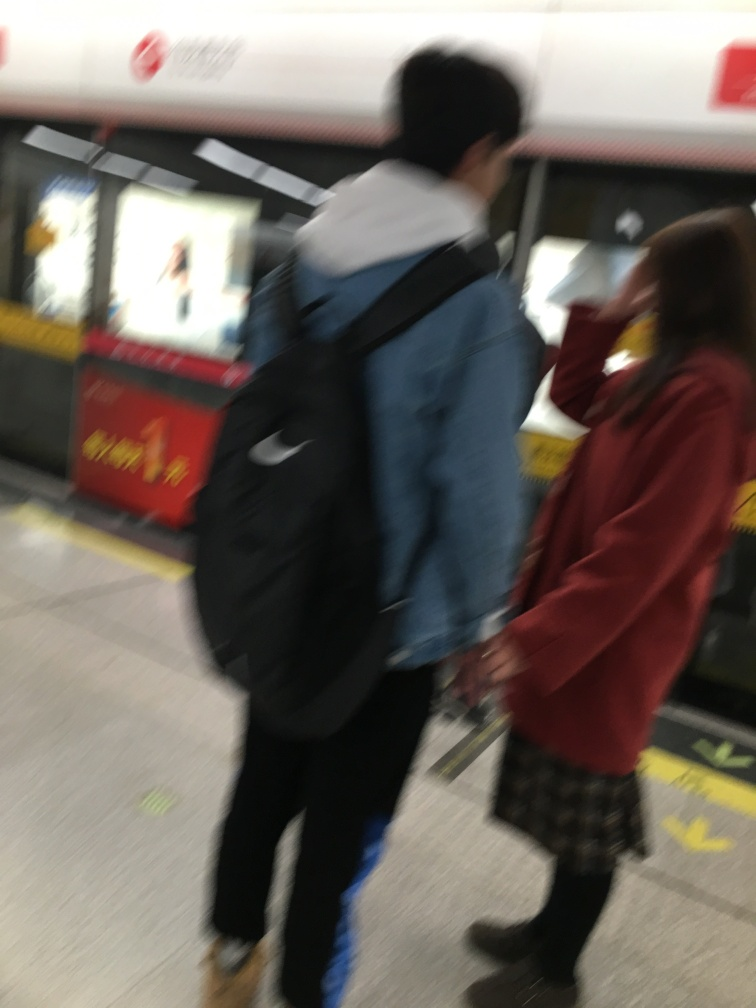Can you describe the scene depicted in the image? The image captures two individuals in a subway station. Due to motion blur, the specifics are indecipherable; however, they appear to be in the middle of an action, possibly walking. 